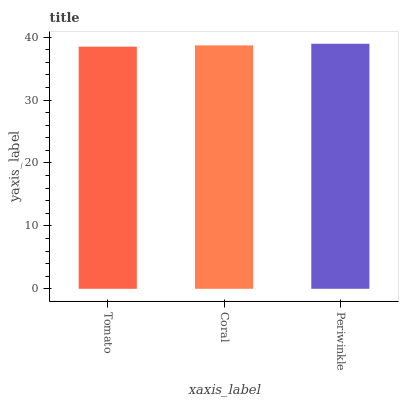Is Tomato the minimum?
Answer yes or no. Yes. Is Periwinkle the maximum?
Answer yes or no. Yes. Is Coral the minimum?
Answer yes or no. No. Is Coral the maximum?
Answer yes or no. No. Is Coral greater than Tomato?
Answer yes or no. Yes. Is Tomato less than Coral?
Answer yes or no. Yes. Is Tomato greater than Coral?
Answer yes or no. No. Is Coral less than Tomato?
Answer yes or no. No. Is Coral the high median?
Answer yes or no. Yes. Is Coral the low median?
Answer yes or no. Yes. Is Periwinkle the high median?
Answer yes or no. No. Is Periwinkle the low median?
Answer yes or no. No. 